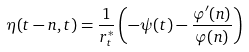<formula> <loc_0><loc_0><loc_500><loc_500>\eta ( t - n , t ) = \frac { 1 } { r ^ { * } _ { t } } \left ( - \psi ( t ) - \frac { \varphi ^ { \prime } ( n ) } { \varphi ( n ) } \right )</formula> 